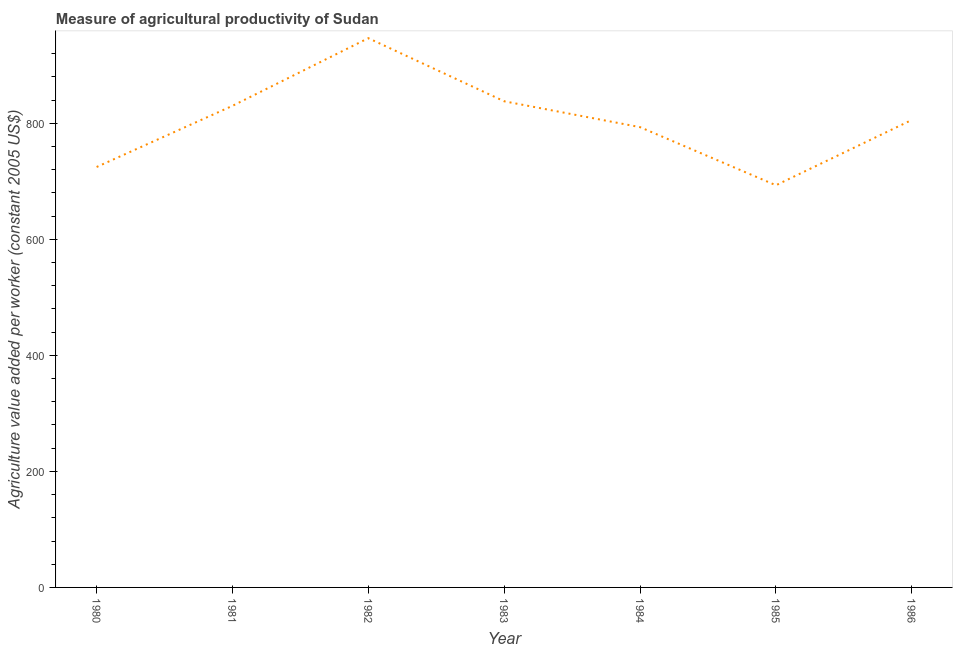What is the agriculture value added per worker in 1985?
Provide a succinct answer. 693.1. Across all years, what is the maximum agriculture value added per worker?
Your response must be concise. 946.58. Across all years, what is the minimum agriculture value added per worker?
Your answer should be very brief. 693.1. In which year was the agriculture value added per worker minimum?
Offer a terse response. 1985. What is the sum of the agriculture value added per worker?
Make the answer very short. 5630.94. What is the difference between the agriculture value added per worker in 1982 and 1984?
Provide a short and direct response. 153.31. What is the average agriculture value added per worker per year?
Your answer should be compact. 804.42. What is the median agriculture value added per worker?
Provide a succinct answer. 805.61. What is the ratio of the agriculture value added per worker in 1982 to that in 1986?
Provide a short and direct response. 1.17. What is the difference between the highest and the second highest agriculture value added per worker?
Your answer should be very brief. 108.75. What is the difference between the highest and the lowest agriculture value added per worker?
Offer a very short reply. 253.48. How many lines are there?
Provide a short and direct response. 1. How many years are there in the graph?
Keep it short and to the point. 7. Are the values on the major ticks of Y-axis written in scientific E-notation?
Ensure brevity in your answer.  No. What is the title of the graph?
Provide a short and direct response. Measure of agricultural productivity of Sudan. What is the label or title of the Y-axis?
Give a very brief answer. Agriculture value added per worker (constant 2005 US$). What is the Agriculture value added per worker (constant 2005 US$) in 1980?
Your response must be concise. 724.57. What is the Agriculture value added per worker (constant 2005 US$) in 1981?
Provide a succinct answer. 829.99. What is the Agriculture value added per worker (constant 2005 US$) of 1982?
Ensure brevity in your answer.  946.58. What is the Agriculture value added per worker (constant 2005 US$) of 1983?
Provide a short and direct response. 837.83. What is the Agriculture value added per worker (constant 2005 US$) of 1984?
Your answer should be very brief. 793.27. What is the Agriculture value added per worker (constant 2005 US$) in 1985?
Your answer should be very brief. 693.1. What is the Agriculture value added per worker (constant 2005 US$) of 1986?
Provide a short and direct response. 805.61. What is the difference between the Agriculture value added per worker (constant 2005 US$) in 1980 and 1981?
Your answer should be compact. -105.42. What is the difference between the Agriculture value added per worker (constant 2005 US$) in 1980 and 1982?
Offer a very short reply. -222.01. What is the difference between the Agriculture value added per worker (constant 2005 US$) in 1980 and 1983?
Keep it short and to the point. -113.26. What is the difference between the Agriculture value added per worker (constant 2005 US$) in 1980 and 1984?
Your answer should be very brief. -68.7. What is the difference between the Agriculture value added per worker (constant 2005 US$) in 1980 and 1985?
Provide a succinct answer. 31.47. What is the difference between the Agriculture value added per worker (constant 2005 US$) in 1980 and 1986?
Make the answer very short. -81.04. What is the difference between the Agriculture value added per worker (constant 2005 US$) in 1981 and 1982?
Your answer should be compact. -116.59. What is the difference between the Agriculture value added per worker (constant 2005 US$) in 1981 and 1983?
Your answer should be compact. -7.84. What is the difference between the Agriculture value added per worker (constant 2005 US$) in 1981 and 1984?
Offer a terse response. 36.72. What is the difference between the Agriculture value added per worker (constant 2005 US$) in 1981 and 1985?
Your answer should be very brief. 136.89. What is the difference between the Agriculture value added per worker (constant 2005 US$) in 1981 and 1986?
Offer a terse response. 24.38. What is the difference between the Agriculture value added per worker (constant 2005 US$) in 1982 and 1983?
Provide a succinct answer. 108.75. What is the difference between the Agriculture value added per worker (constant 2005 US$) in 1982 and 1984?
Your response must be concise. 153.31. What is the difference between the Agriculture value added per worker (constant 2005 US$) in 1982 and 1985?
Offer a very short reply. 253.48. What is the difference between the Agriculture value added per worker (constant 2005 US$) in 1982 and 1986?
Provide a succinct answer. 140.97. What is the difference between the Agriculture value added per worker (constant 2005 US$) in 1983 and 1984?
Give a very brief answer. 44.56. What is the difference between the Agriculture value added per worker (constant 2005 US$) in 1983 and 1985?
Make the answer very short. 144.73. What is the difference between the Agriculture value added per worker (constant 2005 US$) in 1983 and 1986?
Provide a short and direct response. 32.23. What is the difference between the Agriculture value added per worker (constant 2005 US$) in 1984 and 1985?
Offer a terse response. 100.17. What is the difference between the Agriculture value added per worker (constant 2005 US$) in 1984 and 1986?
Keep it short and to the point. -12.34. What is the difference between the Agriculture value added per worker (constant 2005 US$) in 1985 and 1986?
Your answer should be compact. -112.5. What is the ratio of the Agriculture value added per worker (constant 2005 US$) in 1980 to that in 1981?
Your response must be concise. 0.87. What is the ratio of the Agriculture value added per worker (constant 2005 US$) in 1980 to that in 1982?
Your answer should be very brief. 0.77. What is the ratio of the Agriculture value added per worker (constant 2005 US$) in 1980 to that in 1983?
Offer a terse response. 0.86. What is the ratio of the Agriculture value added per worker (constant 2005 US$) in 1980 to that in 1985?
Keep it short and to the point. 1.04. What is the ratio of the Agriculture value added per worker (constant 2005 US$) in 1980 to that in 1986?
Offer a very short reply. 0.9. What is the ratio of the Agriculture value added per worker (constant 2005 US$) in 1981 to that in 1982?
Make the answer very short. 0.88. What is the ratio of the Agriculture value added per worker (constant 2005 US$) in 1981 to that in 1983?
Your response must be concise. 0.99. What is the ratio of the Agriculture value added per worker (constant 2005 US$) in 1981 to that in 1984?
Make the answer very short. 1.05. What is the ratio of the Agriculture value added per worker (constant 2005 US$) in 1981 to that in 1985?
Provide a succinct answer. 1.2. What is the ratio of the Agriculture value added per worker (constant 2005 US$) in 1982 to that in 1983?
Offer a terse response. 1.13. What is the ratio of the Agriculture value added per worker (constant 2005 US$) in 1982 to that in 1984?
Offer a very short reply. 1.19. What is the ratio of the Agriculture value added per worker (constant 2005 US$) in 1982 to that in 1985?
Your response must be concise. 1.37. What is the ratio of the Agriculture value added per worker (constant 2005 US$) in 1982 to that in 1986?
Ensure brevity in your answer.  1.18. What is the ratio of the Agriculture value added per worker (constant 2005 US$) in 1983 to that in 1984?
Your answer should be compact. 1.06. What is the ratio of the Agriculture value added per worker (constant 2005 US$) in 1983 to that in 1985?
Your answer should be compact. 1.21. What is the ratio of the Agriculture value added per worker (constant 2005 US$) in 1984 to that in 1985?
Provide a succinct answer. 1.15. What is the ratio of the Agriculture value added per worker (constant 2005 US$) in 1985 to that in 1986?
Provide a short and direct response. 0.86. 